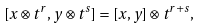Convert formula to latex. <formula><loc_0><loc_0><loc_500><loc_500>[ x \otimes t ^ { r } , y \otimes t ^ { s } ] = [ x , y ] \otimes t ^ { r + s } ,</formula> 